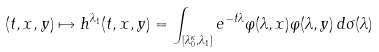<formula> <loc_0><loc_0><loc_500><loc_500>( t , x , y ) \mapsto h ^ { \lambda _ { 1 } } ( t , x , y ) = \int _ { [ \lambda _ { 0 } ^ { \kappa } , \lambda _ { 1 } ] } e ^ { - t \lambda } \varphi ( \lambda , x ) \varphi ( \lambda , y ) \, d \sigma ( \lambda )</formula> 